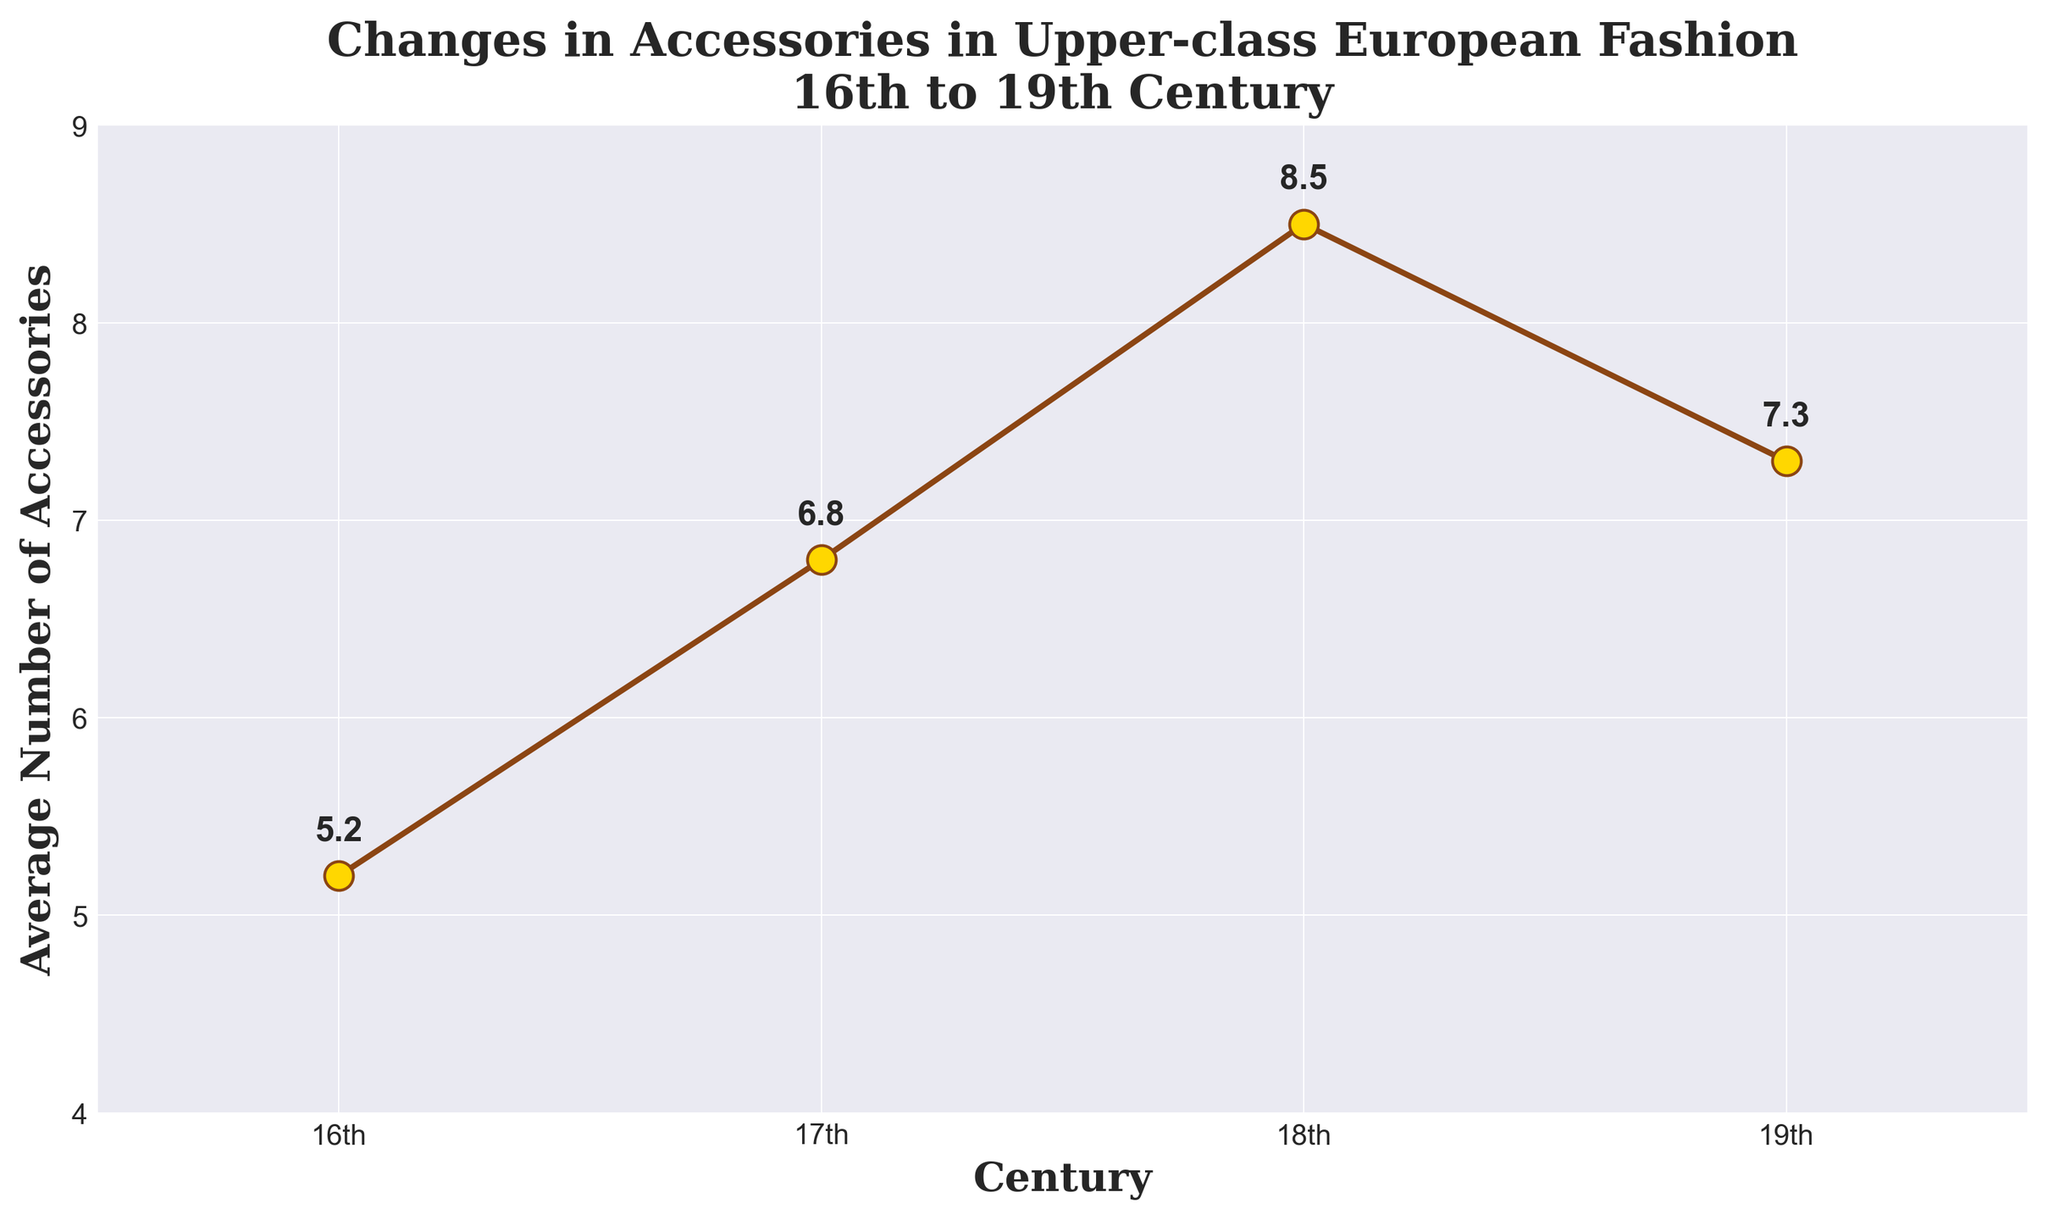What is the average number of accessories worn in the 18th century? Locate the point representing the 18th century on the x-axis and read its corresponding y-axis value, which is 8.5.
Answer: 8.5 During which century did the average number of accessories peak? Observe the data points on the y-axis to find the highest value, which is 8.5 in the 18th century.
Answer: 18th century How does the average number of accessories in the 16th century compare to the 19th century? Compare the y-axis values for the 16th century (5.2) and the 19th century (7.3). Since 7.3 is greater than 5.2, the average number of accessories increased from the 16th to the 19th century.
Answer: Increased By how many accessories did the average number increase from the 16th to the 17th century? Subtract the average number of accessories in the 16th century (5.2) from that in the 17th century (6.8): 6.8 - 5.2.
Answer: 1.6 What is the overall trend of the average number of accessories from the 16th to the 19th century? Observe the general direction in which the plot points move across the centuries: They increase from the 16th to the 18th century and then decrease in the 19th century.
Answer: Increasing, then decreasing What was the difference in the average number of accessories between the centuries with the highest (18th century) and lowest (16th century) values? Subtract the lowest value (5.2 in the 16th century) from the highest value (8.5 in the 18th century): 8.5 - 5.2.
Answer: 3.3 Which century saw the largest increase in the average number of accessories from the previous century? Calculate the differences: 17th - 16th: 6.8 - 5.2 = 1.6, 18th - 17th: 8.5 - 6.8 = 1.7, 19th - 18th: 7.3 - 8.5 = -1.2. The largest positive difference is from the 17th to the 18th century (1.7).
Answer: 18th century What pattern is noticeable in the data representation through points and lines on the chart? The plot points with lines increase from the 16th to the 18th century and then decrease in the 19th century, creating an upward slope followed by a downward slope.
Answer: Upward then downward trend 